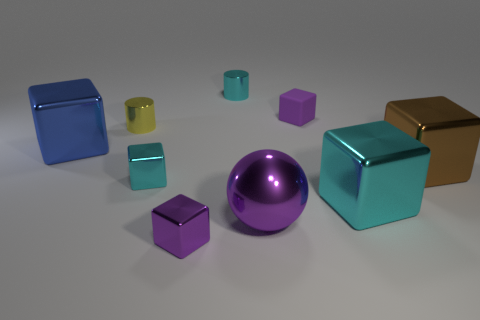Subtract all tiny cyan cubes. How many cubes are left? 5 Subtract all purple blocks. How many blocks are left? 4 Subtract all cylinders. How many objects are left? 7 Add 1 purple metal things. How many objects exist? 10 Add 6 large shiny things. How many large shiny things are left? 10 Add 6 big cubes. How many big cubes exist? 9 Subtract 1 yellow cylinders. How many objects are left? 8 Subtract 1 balls. How many balls are left? 0 Subtract all purple cylinders. Subtract all gray spheres. How many cylinders are left? 2 Subtract all red spheres. How many yellow cylinders are left? 1 